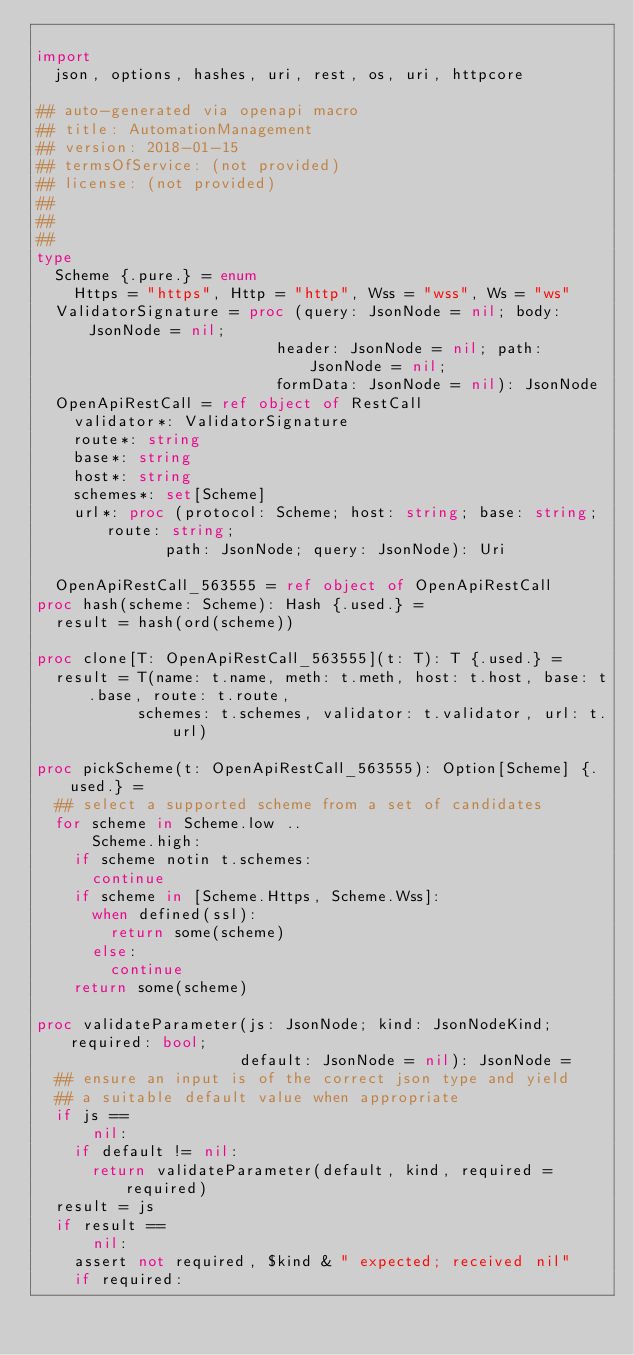<code> <loc_0><loc_0><loc_500><loc_500><_Nim_>
import
  json, options, hashes, uri, rest, os, uri, httpcore

## auto-generated via openapi macro
## title: AutomationManagement
## version: 2018-01-15
## termsOfService: (not provided)
## license: (not provided)
## 
## 
## 
type
  Scheme {.pure.} = enum
    Https = "https", Http = "http", Wss = "wss", Ws = "ws"
  ValidatorSignature = proc (query: JsonNode = nil; body: JsonNode = nil;
                          header: JsonNode = nil; path: JsonNode = nil;
                          formData: JsonNode = nil): JsonNode
  OpenApiRestCall = ref object of RestCall
    validator*: ValidatorSignature
    route*: string
    base*: string
    host*: string
    schemes*: set[Scheme]
    url*: proc (protocol: Scheme; host: string; base: string; route: string;
              path: JsonNode; query: JsonNode): Uri

  OpenApiRestCall_563555 = ref object of OpenApiRestCall
proc hash(scheme: Scheme): Hash {.used.} =
  result = hash(ord(scheme))

proc clone[T: OpenApiRestCall_563555](t: T): T {.used.} =
  result = T(name: t.name, meth: t.meth, host: t.host, base: t.base, route: t.route,
           schemes: t.schemes, validator: t.validator, url: t.url)

proc pickScheme(t: OpenApiRestCall_563555): Option[Scheme] {.used.} =
  ## select a supported scheme from a set of candidates
  for scheme in Scheme.low ..
      Scheme.high:
    if scheme notin t.schemes:
      continue
    if scheme in [Scheme.Https, Scheme.Wss]:
      when defined(ssl):
        return some(scheme)
      else:
        continue
    return some(scheme)

proc validateParameter(js: JsonNode; kind: JsonNodeKind; required: bool;
                      default: JsonNode = nil): JsonNode =
  ## ensure an input is of the correct json type and yield
  ## a suitable default value when appropriate
  if js ==
      nil:
    if default != nil:
      return validateParameter(default, kind, required = required)
  result = js
  if result ==
      nil:
    assert not required, $kind & " expected; received nil"
    if required:</code> 